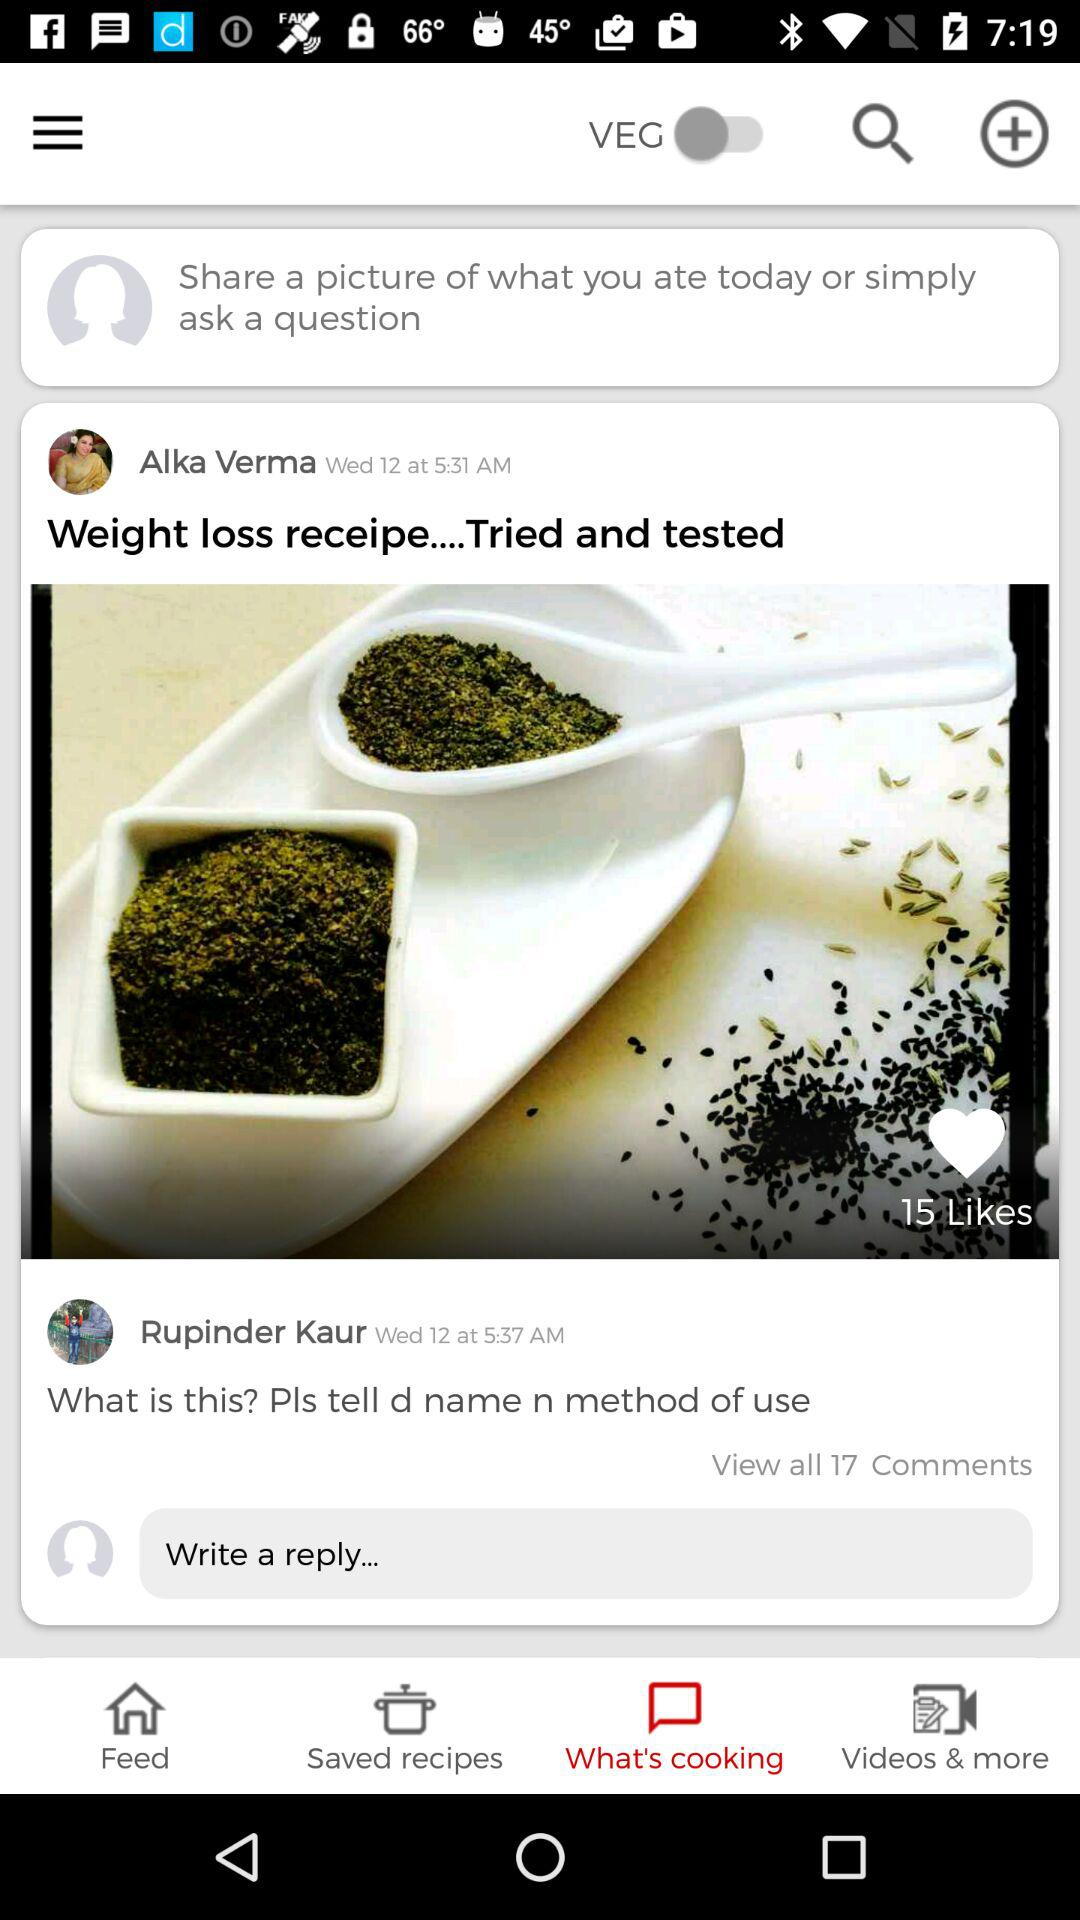What are the names? The names are Alka Verma and Rupinder Kaur. 